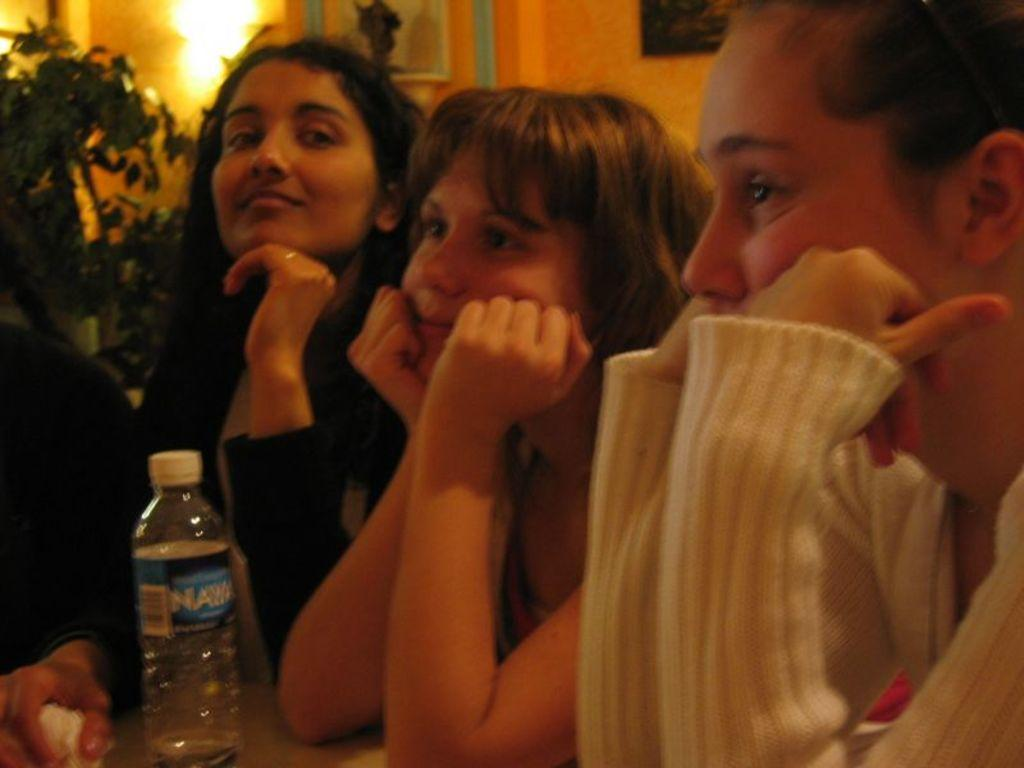How many girls are present in the image? There are three girls sitting in the image. What are the girls doing in the image? The girls are folding their hands. What can be seen near the girls in the image? There is a water bottle and a plant behind the girls. What is on the left side of the image? There is a wall on the left side of the image. Can you describe the lighting in the image? There is light visible in the image. What type of trousers are the girls wearing in the image? The provided facts do not mention the type of trousers the girls are wearing, so we cannot determine that information from the image. What is the value of the plant behind the girls in the image? The value of the plant cannot be determined from the image, as it is not a quantifiable characteristic. 